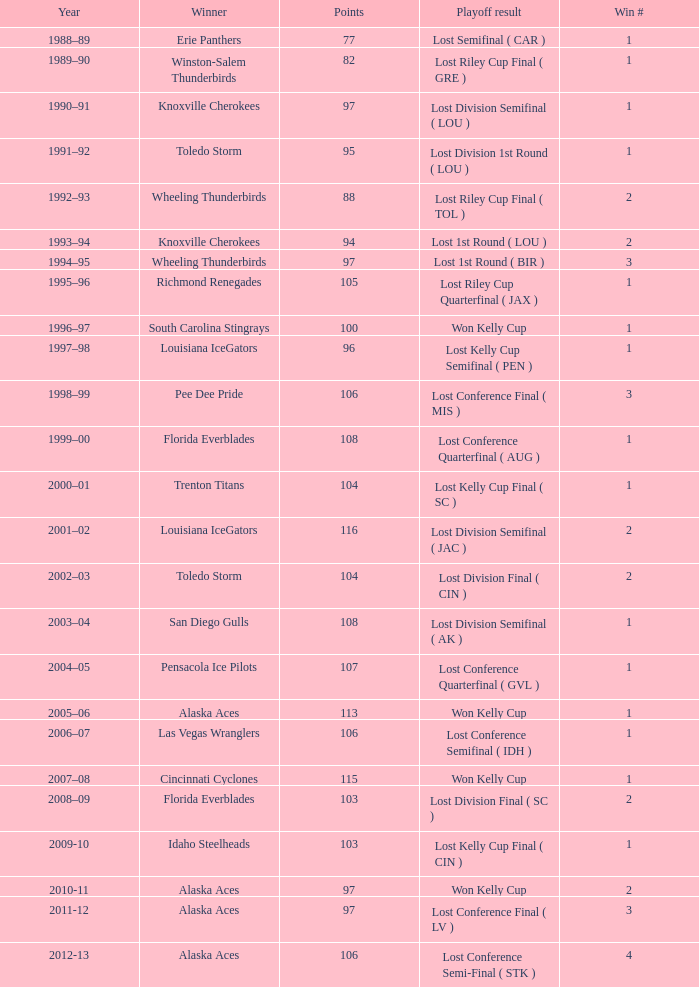What is the lowest Win #, when Year is "2011-12", and when Points is less than 97? None. 